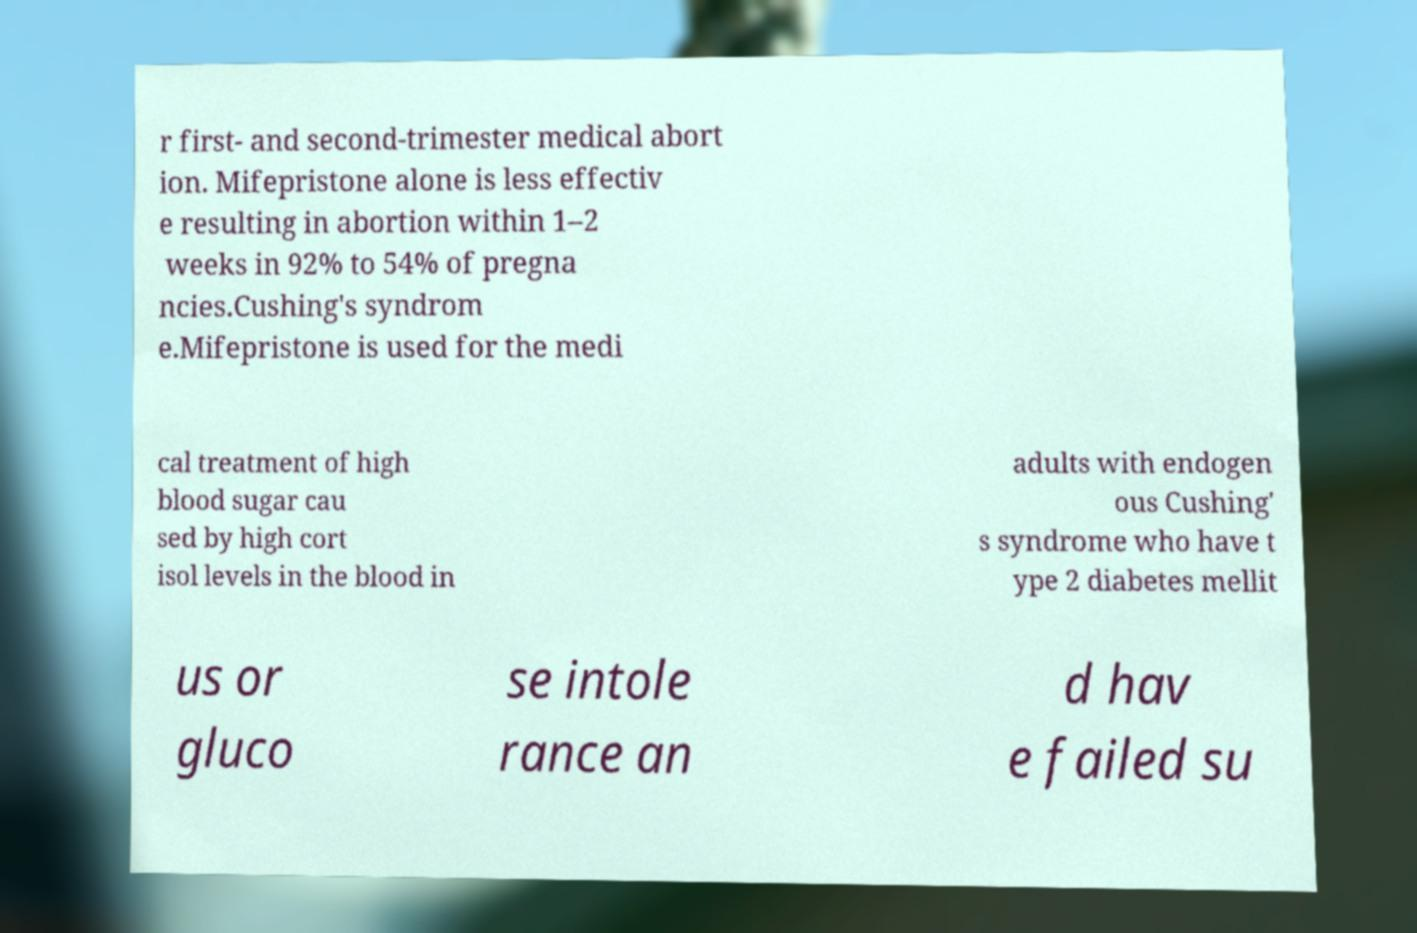Please identify and transcribe the text found in this image. r first- and second-trimester medical abort ion. Mifepristone alone is less effectiv e resulting in abortion within 1–2 weeks in 92% to 54% of pregna ncies.Cushing's syndrom e.Mifepristone is used for the medi cal treatment of high blood sugar cau sed by high cort isol levels in the blood in adults with endogen ous Cushing' s syndrome who have t ype 2 diabetes mellit us or gluco se intole rance an d hav e failed su 